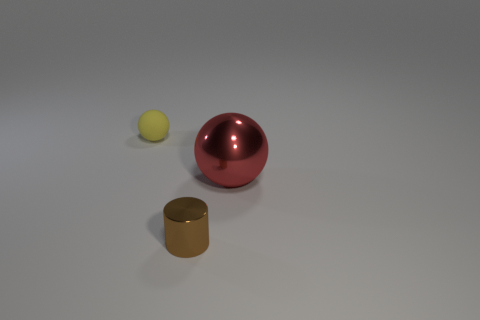How many cylinders are small yellow rubber objects or red objects?
Offer a very short reply. 0. Is the number of tiny yellow matte things that are left of the big metallic sphere less than the number of brown rubber objects?
Your response must be concise. No. What is the shape of the large red thing that is made of the same material as the brown cylinder?
Give a very brief answer. Sphere. How many objects are either big blue rubber cylinders or small objects?
Your response must be concise. 2. What material is the thing that is behind the shiny object behind the small brown shiny cylinder?
Your response must be concise. Rubber. Are there any small brown objects that have the same material as the big ball?
Provide a succinct answer. Yes. There is a small yellow rubber thing that is left of the sphere that is on the right side of the metal cylinder that is in front of the big metal thing; what is its shape?
Your answer should be very brief. Sphere. What is the brown cylinder made of?
Provide a succinct answer. Metal. The sphere that is the same material as the small cylinder is what color?
Make the answer very short. Red. Is there a large metallic sphere that is right of the ball on the right side of the brown object?
Give a very brief answer. No. 